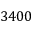<formula> <loc_0><loc_0><loc_500><loc_500>3 4 0 0</formula> 